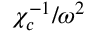Convert formula to latex. <formula><loc_0><loc_0><loc_500><loc_500>{ \chi _ { c } ^ { - 1 } } / { \omega ^ { 2 } }</formula> 